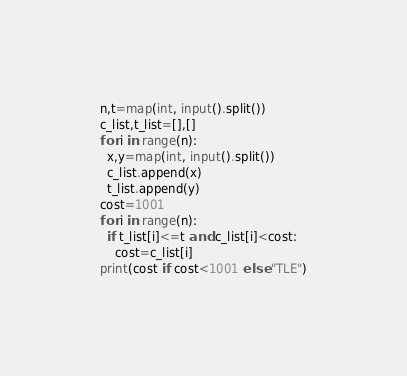Convert code to text. <code><loc_0><loc_0><loc_500><loc_500><_Python_>n,t=map(int, input().split())
c_list,t_list=[],[]
for i in range(n):
  x,y=map(int, input().split())
  c_list.append(x)
  t_list.append(y)
cost=1001
for i in range(n):
  if t_list[i]<=t and c_list[i]<cost:
    cost=c_list[i]
print(cost if cost<1001 else "TLE")</code> 